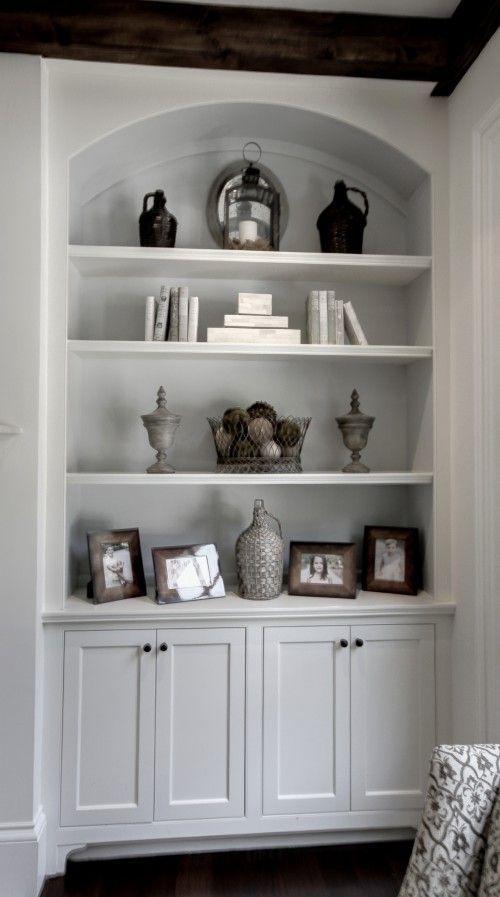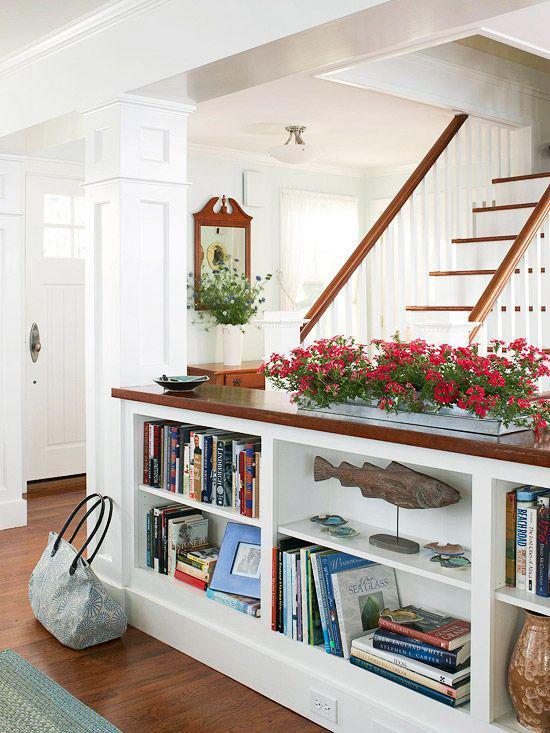The first image is the image on the left, the second image is the image on the right. Assess this claim about the two images: "There is a clock on the shelf in the image on the left.". Correct or not? Answer yes or no. No. 